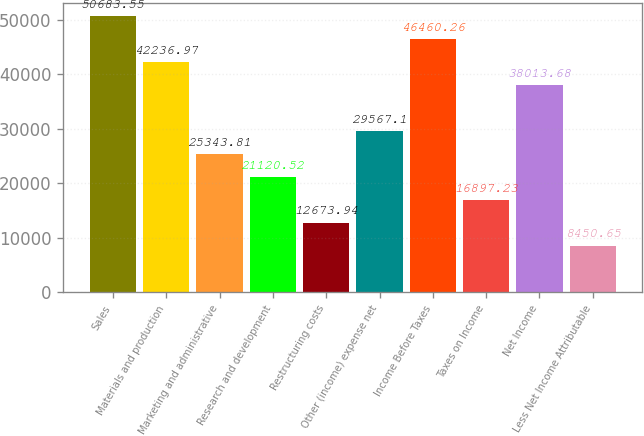Convert chart. <chart><loc_0><loc_0><loc_500><loc_500><bar_chart><fcel>Sales<fcel>Materials and production<fcel>Marketing and administrative<fcel>Research and development<fcel>Restructuring costs<fcel>Other (income) expense net<fcel>Income Before Taxes<fcel>Taxes on Income<fcel>Net Income<fcel>Less Net Income Attributable<nl><fcel>50683.6<fcel>42237<fcel>25343.8<fcel>21120.5<fcel>12673.9<fcel>29567.1<fcel>46460.3<fcel>16897.2<fcel>38013.7<fcel>8450.65<nl></chart> 